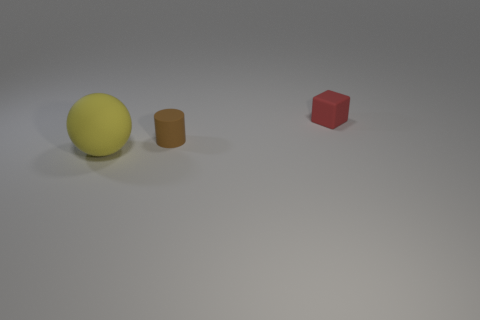Can you estimate the size of these objects relative to each other? While it's difficult to provide precise measurements without context, the yellow sphere appears to be the largest object, followed by the red cube, and finally the brown cylinder which is the smallest in height but comparable in diameter to the cube. 